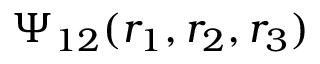<formula> <loc_0><loc_0><loc_500><loc_500>\Psi _ { 1 2 } ( r _ { 1 } , r _ { 2 } , r _ { 3 } )</formula> 